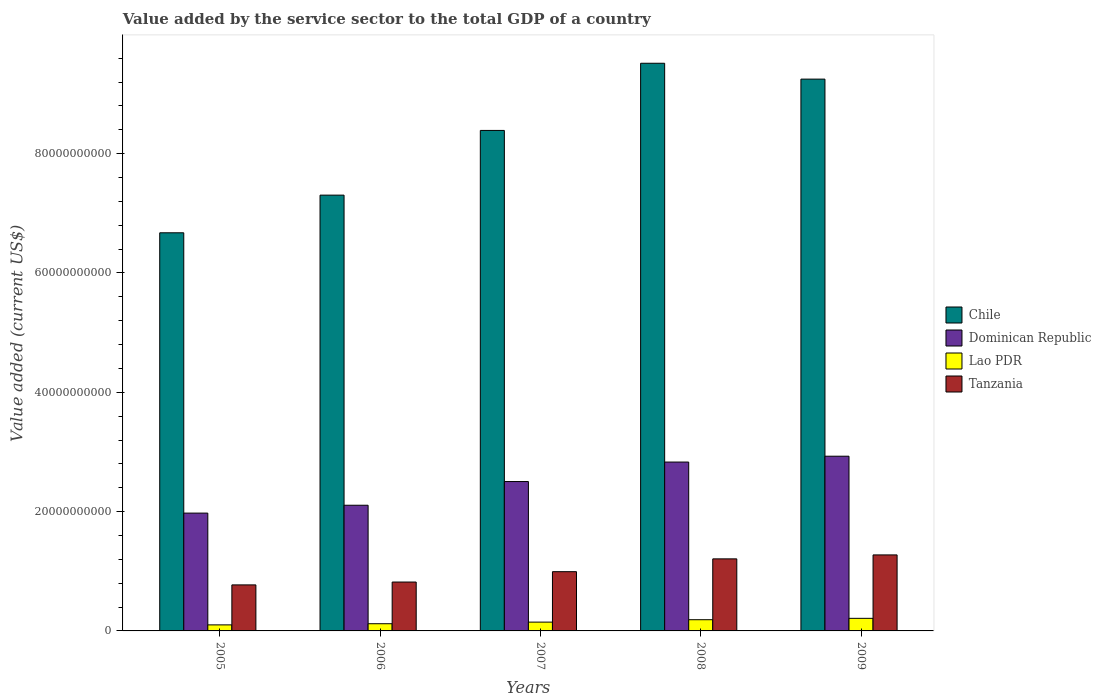How many groups of bars are there?
Provide a succinct answer. 5. Are the number of bars per tick equal to the number of legend labels?
Give a very brief answer. Yes. What is the label of the 5th group of bars from the left?
Your answer should be compact. 2009. What is the value added by the service sector to the total GDP in Lao PDR in 2006?
Provide a succinct answer. 1.21e+09. Across all years, what is the maximum value added by the service sector to the total GDP in Lao PDR?
Ensure brevity in your answer.  2.11e+09. Across all years, what is the minimum value added by the service sector to the total GDP in Chile?
Offer a terse response. 6.67e+1. In which year was the value added by the service sector to the total GDP in Dominican Republic maximum?
Make the answer very short. 2009. What is the total value added by the service sector to the total GDP in Tanzania in the graph?
Offer a terse response. 5.07e+1. What is the difference between the value added by the service sector to the total GDP in Tanzania in 2005 and that in 2008?
Make the answer very short. -4.36e+09. What is the difference between the value added by the service sector to the total GDP in Tanzania in 2007 and the value added by the service sector to the total GDP in Chile in 2009?
Provide a short and direct response. -8.26e+1. What is the average value added by the service sector to the total GDP in Chile per year?
Offer a terse response. 8.23e+1. In the year 2008, what is the difference between the value added by the service sector to the total GDP in Chile and value added by the service sector to the total GDP in Tanzania?
Ensure brevity in your answer.  8.31e+1. What is the ratio of the value added by the service sector to the total GDP in Tanzania in 2007 to that in 2009?
Provide a succinct answer. 0.78. Is the value added by the service sector to the total GDP in Dominican Republic in 2007 less than that in 2008?
Your response must be concise. Yes. What is the difference between the highest and the second highest value added by the service sector to the total GDP in Tanzania?
Your answer should be compact. 6.62e+08. What is the difference between the highest and the lowest value added by the service sector to the total GDP in Chile?
Give a very brief answer. 2.84e+1. In how many years, is the value added by the service sector to the total GDP in Tanzania greater than the average value added by the service sector to the total GDP in Tanzania taken over all years?
Provide a short and direct response. 2. Is the sum of the value added by the service sector to the total GDP in Tanzania in 2006 and 2008 greater than the maximum value added by the service sector to the total GDP in Lao PDR across all years?
Your answer should be compact. Yes. What does the 4th bar from the left in 2006 represents?
Offer a terse response. Tanzania. What does the 1st bar from the right in 2009 represents?
Keep it short and to the point. Tanzania. Is it the case that in every year, the sum of the value added by the service sector to the total GDP in Chile and value added by the service sector to the total GDP in Lao PDR is greater than the value added by the service sector to the total GDP in Dominican Republic?
Ensure brevity in your answer.  Yes. Are all the bars in the graph horizontal?
Offer a terse response. No. What is the difference between two consecutive major ticks on the Y-axis?
Keep it short and to the point. 2.00e+1. Are the values on the major ticks of Y-axis written in scientific E-notation?
Give a very brief answer. No. Does the graph contain any zero values?
Offer a very short reply. No. Where does the legend appear in the graph?
Offer a very short reply. Center right. How many legend labels are there?
Provide a succinct answer. 4. How are the legend labels stacked?
Your answer should be very brief. Vertical. What is the title of the graph?
Give a very brief answer. Value added by the service sector to the total GDP of a country. What is the label or title of the Y-axis?
Provide a short and direct response. Value added (current US$). What is the Value added (current US$) in Chile in 2005?
Provide a succinct answer. 6.67e+1. What is the Value added (current US$) of Dominican Republic in 2005?
Keep it short and to the point. 1.97e+1. What is the Value added (current US$) of Lao PDR in 2005?
Keep it short and to the point. 1.01e+09. What is the Value added (current US$) in Tanzania in 2005?
Keep it short and to the point. 7.71e+09. What is the Value added (current US$) in Chile in 2006?
Offer a very short reply. 7.30e+1. What is the Value added (current US$) in Dominican Republic in 2006?
Your response must be concise. 2.11e+1. What is the Value added (current US$) in Lao PDR in 2006?
Give a very brief answer. 1.21e+09. What is the Value added (current US$) of Tanzania in 2006?
Provide a short and direct response. 8.19e+09. What is the Value added (current US$) in Chile in 2007?
Give a very brief answer. 8.39e+1. What is the Value added (current US$) in Dominican Republic in 2007?
Provide a short and direct response. 2.50e+1. What is the Value added (current US$) of Lao PDR in 2007?
Your response must be concise. 1.48e+09. What is the Value added (current US$) in Tanzania in 2007?
Make the answer very short. 9.93e+09. What is the Value added (current US$) of Chile in 2008?
Your response must be concise. 9.51e+1. What is the Value added (current US$) of Dominican Republic in 2008?
Give a very brief answer. 2.83e+1. What is the Value added (current US$) of Lao PDR in 2008?
Give a very brief answer. 1.88e+09. What is the Value added (current US$) in Tanzania in 2008?
Make the answer very short. 1.21e+1. What is the Value added (current US$) in Chile in 2009?
Keep it short and to the point. 9.25e+1. What is the Value added (current US$) in Dominican Republic in 2009?
Ensure brevity in your answer.  2.93e+1. What is the Value added (current US$) of Lao PDR in 2009?
Provide a succinct answer. 2.11e+09. What is the Value added (current US$) of Tanzania in 2009?
Offer a very short reply. 1.27e+1. Across all years, what is the maximum Value added (current US$) in Chile?
Give a very brief answer. 9.51e+1. Across all years, what is the maximum Value added (current US$) of Dominican Republic?
Offer a very short reply. 2.93e+1. Across all years, what is the maximum Value added (current US$) in Lao PDR?
Your answer should be compact. 2.11e+09. Across all years, what is the maximum Value added (current US$) in Tanzania?
Make the answer very short. 1.27e+1. Across all years, what is the minimum Value added (current US$) in Chile?
Offer a very short reply. 6.67e+1. Across all years, what is the minimum Value added (current US$) in Dominican Republic?
Offer a very short reply. 1.97e+1. Across all years, what is the minimum Value added (current US$) in Lao PDR?
Give a very brief answer. 1.01e+09. Across all years, what is the minimum Value added (current US$) in Tanzania?
Keep it short and to the point. 7.71e+09. What is the total Value added (current US$) of Chile in the graph?
Offer a terse response. 4.11e+11. What is the total Value added (current US$) of Dominican Republic in the graph?
Keep it short and to the point. 1.23e+11. What is the total Value added (current US$) in Lao PDR in the graph?
Your answer should be compact. 7.68e+09. What is the total Value added (current US$) of Tanzania in the graph?
Keep it short and to the point. 5.07e+1. What is the difference between the Value added (current US$) in Chile in 2005 and that in 2006?
Provide a short and direct response. -6.31e+09. What is the difference between the Value added (current US$) of Dominican Republic in 2005 and that in 2006?
Offer a terse response. -1.32e+09. What is the difference between the Value added (current US$) of Lao PDR in 2005 and that in 2006?
Your response must be concise. -1.94e+08. What is the difference between the Value added (current US$) in Tanzania in 2005 and that in 2006?
Your answer should be compact. -4.79e+08. What is the difference between the Value added (current US$) in Chile in 2005 and that in 2007?
Your response must be concise. -1.72e+1. What is the difference between the Value added (current US$) in Dominican Republic in 2005 and that in 2007?
Your answer should be very brief. -5.29e+09. What is the difference between the Value added (current US$) in Lao PDR in 2005 and that in 2007?
Provide a succinct answer. -4.64e+08. What is the difference between the Value added (current US$) in Tanzania in 2005 and that in 2007?
Offer a very short reply. -2.21e+09. What is the difference between the Value added (current US$) of Chile in 2005 and that in 2008?
Keep it short and to the point. -2.84e+1. What is the difference between the Value added (current US$) of Dominican Republic in 2005 and that in 2008?
Your answer should be compact. -8.56e+09. What is the difference between the Value added (current US$) in Lao PDR in 2005 and that in 2008?
Your response must be concise. -8.67e+08. What is the difference between the Value added (current US$) in Tanzania in 2005 and that in 2008?
Your response must be concise. -4.36e+09. What is the difference between the Value added (current US$) of Chile in 2005 and that in 2009?
Make the answer very short. -2.58e+1. What is the difference between the Value added (current US$) of Dominican Republic in 2005 and that in 2009?
Offer a terse response. -9.54e+09. What is the difference between the Value added (current US$) in Lao PDR in 2005 and that in 2009?
Keep it short and to the point. -1.10e+09. What is the difference between the Value added (current US$) in Tanzania in 2005 and that in 2009?
Make the answer very short. -5.02e+09. What is the difference between the Value added (current US$) in Chile in 2006 and that in 2007?
Ensure brevity in your answer.  -1.08e+1. What is the difference between the Value added (current US$) in Dominican Republic in 2006 and that in 2007?
Your response must be concise. -3.97e+09. What is the difference between the Value added (current US$) in Lao PDR in 2006 and that in 2007?
Keep it short and to the point. -2.70e+08. What is the difference between the Value added (current US$) in Tanzania in 2006 and that in 2007?
Offer a terse response. -1.73e+09. What is the difference between the Value added (current US$) in Chile in 2006 and that in 2008?
Provide a succinct answer. -2.21e+1. What is the difference between the Value added (current US$) of Dominican Republic in 2006 and that in 2008?
Offer a terse response. -7.24e+09. What is the difference between the Value added (current US$) in Lao PDR in 2006 and that in 2008?
Ensure brevity in your answer.  -6.73e+08. What is the difference between the Value added (current US$) of Tanzania in 2006 and that in 2008?
Keep it short and to the point. -3.88e+09. What is the difference between the Value added (current US$) in Chile in 2006 and that in 2009?
Keep it short and to the point. -1.94e+1. What is the difference between the Value added (current US$) of Dominican Republic in 2006 and that in 2009?
Your response must be concise. -8.22e+09. What is the difference between the Value added (current US$) in Lao PDR in 2006 and that in 2009?
Keep it short and to the point. -9.02e+08. What is the difference between the Value added (current US$) of Tanzania in 2006 and that in 2009?
Give a very brief answer. -4.55e+09. What is the difference between the Value added (current US$) in Chile in 2007 and that in 2008?
Your answer should be compact. -1.13e+1. What is the difference between the Value added (current US$) in Dominican Republic in 2007 and that in 2008?
Give a very brief answer. -3.27e+09. What is the difference between the Value added (current US$) of Lao PDR in 2007 and that in 2008?
Your answer should be very brief. -4.03e+08. What is the difference between the Value added (current US$) in Tanzania in 2007 and that in 2008?
Offer a very short reply. -2.15e+09. What is the difference between the Value added (current US$) in Chile in 2007 and that in 2009?
Make the answer very short. -8.60e+09. What is the difference between the Value added (current US$) in Dominican Republic in 2007 and that in 2009?
Offer a very short reply. -4.25e+09. What is the difference between the Value added (current US$) of Lao PDR in 2007 and that in 2009?
Your answer should be very brief. -6.32e+08. What is the difference between the Value added (current US$) of Tanzania in 2007 and that in 2009?
Offer a terse response. -2.81e+09. What is the difference between the Value added (current US$) in Chile in 2008 and that in 2009?
Your answer should be compact. 2.66e+09. What is the difference between the Value added (current US$) in Dominican Republic in 2008 and that in 2009?
Your response must be concise. -9.80e+08. What is the difference between the Value added (current US$) in Lao PDR in 2008 and that in 2009?
Make the answer very short. -2.29e+08. What is the difference between the Value added (current US$) of Tanzania in 2008 and that in 2009?
Your answer should be very brief. -6.62e+08. What is the difference between the Value added (current US$) of Chile in 2005 and the Value added (current US$) of Dominican Republic in 2006?
Provide a short and direct response. 4.57e+1. What is the difference between the Value added (current US$) of Chile in 2005 and the Value added (current US$) of Lao PDR in 2006?
Offer a very short reply. 6.55e+1. What is the difference between the Value added (current US$) in Chile in 2005 and the Value added (current US$) in Tanzania in 2006?
Provide a short and direct response. 5.85e+1. What is the difference between the Value added (current US$) of Dominican Republic in 2005 and the Value added (current US$) of Lao PDR in 2006?
Provide a succinct answer. 1.85e+1. What is the difference between the Value added (current US$) in Dominican Republic in 2005 and the Value added (current US$) in Tanzania in 2006?
Offer a terse response. 1.16e+1. What is the difference between the Value added (current US$) in Lao PDR in 2005 and the Value added (current US$) in Tanzania in 2006?
Give a very brief answer. -7.18e+09. What is the difference between the Value added (current US$) of Chile in 2005 and the Value added (current US$) of Dominican Republic in 2007?
Your answer should be very brief. 4.17e+1. What is the difference between the Value added (current US$) in Chile in 2005 and the Value added (current US$) in Lao PDR in 2007?
Offer a very short reply. 6.53e+1. What is the difference between the Value added (current US$) in Chile in 2005 and the Value added (current US$) in Tanzania in 2007?
Provide a short and direct response. 5.68e+1. What is the difference between the Value added (current US$) of Dominican Republic in 2005 and the Value added (current US$) of Lao PDR in 2007?
Keep it short and to the point. 1.83e+1. What is the difference between the Value added (current US$) of Dominican Republic in 2005 and the Value added (current US$) of Tanzania in 2007?
Your answer should be compact. 9.82e+09. What is the difference between the Value added (current US$) in Lao PDR in 2005 and the Value added (current US$) in Tanzania in 2007?
Your answer should be very brief. -8.92e+09. What is the difference between the Value added (current US$) of Chile in 2005 and the Value added (current US$) of Dominican Republic in 2008?
Offer a terse response. 3.84e+1. What is the difference between the Value added (current US$) of Chile in 2005 and the Value added (current US$) of Lao PDR in 2008?
Provide a succinct answer. 6.49e+1. What is the difference between the Value added (current US$) of Chile in 2005 and the Value added (current US$) of Tanzania in 2008?
Ensure brevity in your answer.  5.47e+1. What is the difference between the Value added (current US$) in Dominican Republic in 2005 and the Value added (current US$) in Lao PDR in 2008?
Your response must be concise. 1.79e+1. What is the difference between the Value added (current US$) in Dominican Republic in 2005 and the Value added (current US$) in Tanzania in 2008?
Offer a very short reply. 7.67e+09. What is the difference between the Value added (current US$) in Lao PDR in 2005 and the Value added (current US$) in Tanzania in 2008?
Your response must be concise. -1.11e+1. What is the difference between the Value added (current US$) of Chile in 2005 and the Value added (current US$) of Dominican Republic in 2009?
Keep it short and to the point. 3.74e+1. What is the difference between the Value added (current US$) in Chile in 2005 and the Value added (current US$) in Lao PDR in 2009?
Make the answer very short. 6.46e+1. What is the difference between the Value added (current US$) in Chile in 2005 and the Value added (current US$) in Tanzania in 2009?
Offer a terse response. 5.40e+1. What is the difference between the Value added (current US$) in Dominican Republic in 2005 and the Value added (current US$) in Lao PDR in 2009?
Offer a terse response. 1.76e+1. What is the difference between the Value added (current US$) of Dominican Republic in 2005 and the Value added (current US$) of Tanzania in 2009?
Your answer should be compact. 7.01e+09. What is the difference between the Value added (current US$) in Lao PDR in 2005 and the Value added (current US$) in Tanzania in 2009?
Give a very brief answer. -1.17e+1. What is the difference between the Value added (current US$) of Chile in 2006 and the Value added (current US$) of Dominican Republic in 2007?
Ensure brevity in your answer.  4.80e+1. What is the difference between the Value added (current US$) in Chile in 2006 and the Value added (current US$) in Lao PDR in 2007?
Ensure brevity in your answer.  7.16e+1. What is the difference between the Value added (current US$) of Chile in 2006 and the Value added (current US$) of Tanzania in 2007?
Provide a succinct answer. 6.31e+1. What is the difference between the Value added (current US$) in Dominican Republic in 2006 and the Value added (current US$) in Lao PDR in 2007?
Provide a short and direct response. 1.96e+1. What is the difference between the Value added (current US$) of Dominican Republic in 2006 and the Value added (current US$) of Tanzania in 2007?
Provide a succinct answer. 1.11e+1. What is the difference between the Value added (current US$) in Lao PDR in 2006 and the Value added (current US$) in Tanzania in 2007?
Your answer should be compact. -8.72e+09. What is the difference between the Value added (current US$) in Chile in 2006 and the Value added (current US$) in Dominican Republic in 2008?
Your answer should be very brief. 4.47e+1. What is the difference between the Value added (current US$) in Chile in 2006 and the Value added (current US$) in Lao PDR in 2008?
Ensure brevity in your answer.  7.12e+1. What is the difference between the Value added (current US$) in Chile in 2006 and the Value added (current US$) in Tanzania in 2008?
Your response must be concise. 6.10e+1. What is the difference between the Value added (current US$) in Dominican Republic in 2006 and the Value added (current US$) in Lao PDR in 2008?
Your response must be concise. 1.92e+1. What is the difference between the Value added (current US$) in Dominican Republic in 2006 and the Value added (current US$) in Tanzania in 2008?
Offer a very short reply. 8.99e+09. What is the difference between the Value added (current US$) of Lao PDR in 2006 and the Value added (current US$) of Tanzania in 2008?
Offer a terse response. -1.09e+1. What is the difference between the Value added (current US$) in Chile in 2006 and the Value added (current US$) in Dominican Republic in 2009?
Make the answer very short. 4.38e+1. What is the difference between the Value added (current US$) in Chile in 2006 and the Value added (current US$) in Lao PDR in 2009?
Give a very brief answer. 7.09e+1. What is the difference between the Value added (current US$) of Chile in 2006 and the Value added (current US$) of Tanzania in 2009?
Your answer should be compact. 6.03e+1. What is the difference between the Value added (current US$) in Dominican Republic in 2006 and the Value added (current US$) in Lao PDR in 2009?
Make the answer very short. 1.90e+1. What is the difference between the Value added (current US$) in Dominican Republic in 2006 and the Value added (current US$) in Tanzania in 2009?
Provide a short and direct response. 8.33e+09. What is the difference between the Value added (current US$) in Lao PDR in 2006 and the Value added (current US$) in Tanzania in 2009?
Ensure brevity in your answer.  -1.15e+1. What is the difference between the Value added (current US$) in Chile in 2007 and the Value added (current US$) in Dominican Republic in 2008?
Provide a short and direct response. 5.56e+1. What is the difference between the Value added (current US$) in Chile in 2007 and the Value added (current US$) in Lao PDR in 2008?
Your response must be concise. 8.20e+1. What is the difference between the Value added (current US$) of Chile in 2007 and the Value added (current US$) of Tanzania in 2008?
Your answer should be very brief. 7.18e+1. What is the difference between the Value added (current US$) of Dominican Republic in 2007 and the Value added (current US$) of Lao PDR in 2008?
Provide a succinct answer. 2.32e+1. What is the difference between the Value added (current US$) in Dominican Republic in 2007 and the Value added (current US$) in Tanzania in 2008?
Your answer should be very brief. 1.30e+1. What is the difference between the Value added (current US$) in Lao PDR in 2007 and the Value added (current US$) in Tanzania in 2008?
Provide a succinct answer. -1.06e+1. What is the difference between the Value added (current US$) in Chile in 2007 and the Value added (current US$) in Dominican Republic in 2009?
Your answer should be compact. 5.46e+1. What is the difference between the Value added (current US$) in Chile in 2007 and the Value added (current US$) in Lao PDR in 2009?
Your response must be concise. 8.18e+1. What is the difference between the Value added (current US$) in Chile in 2007 and the Value added (current US$) in Tanzania in 2009?
Your answer should be very brief. 7.11e+1. What is the difference between the Value added (current US$) in Dominican Republic in 2007 and the Value added (current US$) in Lao PDR in 2009?
Your answer should be compact. 2.29e+1. What is the difference between the Value added (current US$) of Dominican Republic in 2007 and the Value added (current US$) of Tanzania in 2009?
Ensure brevity in your answer.  1.23e+1. What is the difference between the Value added (current US$) in Lao PDR in 2007 and the Value added (current US$) in Tanzania in 2009?
Ensure brevity in your answer.  -1.13e+1. What is the difference between the Value added (current US$) of Chile in 2008 and the Value added (current US$) of Dominican Republic in 2009?
Offer a very short reply. 6.59e+1. What is the difference between the Value added (current US$) in Chile in 2008 and the Value added (current US$) in Lao PDR in 2009?
Provide a short and direct response. 9.30e+1. What is the difference between the Value added (current US$) of Chile in 2008 and the Value added (current US$) of Tanzania in 2009?
Keep it short and to the point. 8.24e+1. What is the difference between the Value added (current US$) of Dominican Republic in 2008 and the Value added (current US$) of Lao PDR in 2009?
Offer a very short reply. 2.62e+1. What is the difference between the Value added (current US$) of Dominican Republic in 2008 and the Value added (current US$) of Tanzania in 2009?
Your answer should be very brief. 1.56e+1. What is the difference between the Value added (current US$) in Lao PDR in 2008 and the Value added (current US$) in Tanzania in 2009?
Your answer should be very brief. -1.09e+1. What is the average Value added (current US$) of Chile per year?
Provide a succinct answer. 8.23e+1. What is the average Value added (current US$) of Dominican Republic per year?
Your answer should be very brief. 2.47e+1. What is the average Value added (current US$) in Lao PDR per year?
Offer a very short reply. 1.54e+09. What is the average Value added (current US$) of Tanzania per year?
Make the answer very short. 1.01e+1. In the year 2005, what is the difference between the Value added (current US$) of Chile and Value added (current US$) of Dominican Republic?
Make the answer very short. 4.70e+1. In the year 2005, what is the difference between the Value added (current US$) of Chile and Value added (current US$) of Lao PDR?
Ensure brevity in your answer.  6.57e+1. In the year 2005, what is the difference between the Value added (current US$) in Chile and Value added (current US$) in Tanzania?
Offer a very short reply. 5.90e+1. In the year 2005, what is the difference between the Value added (current US$) in Dominican Republic and Value added (current US$) in Lao PDR?
Offer a very short reply. 1.87e+1. In the year 2005, what is the difference between the Value added (current US$) of Dominican Republic and Value added (current US$) of Tanzania?
Your response must be concise. 1.20e+1. In the year 2005, what is the difference between the Value added (current US$) in Lao PDR and Value added (current US$) in Tanzania?
Ensure brevity in your answer.  -6.70e+09. In the year 2006, what is the difference between the Value added (current US$) in Chile and Value added (current US$) in Dominican Republic?
Your answer should be very brief. 5.20e+1. In the year 2006, what is the difference between the Value added (current US$) of Chile and Value added (current US$) of Lao PDR?
Your answer should be very brief. 7.18e+1. In the year 2006, what is the difference between the Value added (current US$) in Chile and Value added (current US$) in Tanzania?
Ensure brevity in your answer.  6.48e+1. In the year 2006, what is the difference between the Value added (current US$) in Dominican Republic and Value added (current US$) in Lao PDR?
Give a very brief answer. 1.99e+1. In the year 2006, what is the difference between the Value added (current US$) of Dominican Republic and Value added (current US$) of Tanzania?
Your answer should be very brief. 1.29e+1. In the year 2006, what is the difference between the Value added (current US$) of Lao PDR and Value added (current US$) of Tanzania?
Provide a short and direct response. -6.99e+09. In the year 2007, what is the difference between the Value added (current US$) of Chile and Value added (current US$) of Dominican Republic?
Make the answer very short. 5.88e+1. In the year 2007, what is the difference between the Value added (current US$) of Chile and Value added (current US$) of Lao PDR?
Offer a terse response. 8.24e+1. In the year 2007, what is the difference between the Value added (current US$) of Chile and Value added (current US$) of Tanzania?
Your answer should be very brief. 7.40e+1. In the year 2007, what is the difference between the Value added (current US$) in Dominican Republic and Value added (current US$) in Lao PDR?
Offer a terse response. 2.36e+1. In the year 2007, what is the difference between the Value added (current US$) in Dominican Republic and Value added (current US$) in Tanzania?
Your answer should be very brief. 1.51e+1. In the year 2007, what is the difference between the Value added (current US$) in Lao PDR and Value added (current US$) in Tanzania?
Make the answer very short. -8.45e+09. In the year 2008, what is the difference between the Value added (current US$) of Chile and Value added (current US$) of Dominican Republic?
Ensure brevity in your answer.  6.68e+1. In the year 2008, what is the difference between the Value added (current US$) of Chile and Value added (current US$) of Lao PDR?
Keep it short and to the point. 9.33e+1. In the year 2008, what is the difference between the Value added (current US$) of Chile and Value added (current US$) of Tanzania?
Your response must be concise. 8.31e+1. In the year 2008, what is the difference between the Value added (current US$) in Dominican Republic and Value added (current US$) in Lao PDR?
Ensure brevity in your answer.  2.64e+1. In the year 2008, what is the difference between the Value added (current US$) of Dominican Republic and Value added (current US$) of Tanzania?
Make the answer very short. 1.62e+1. In the year 2008, what is the difference between the Value added (current US$) in Lao PDR and Value added (current US$) in Tanzania?
Your response must be concise. -1.02e+1. In the year 2009, what is the difference between the Value added (current US$) in Chile and Value added (current US$) in Dominican Republic?
Offer a very short reply. 6.32e+1. In the year 2009, what is the difference between the Value added (current US$) in Chile and Value added (current US$) in Lao PDR?
Your response must be concise. 9.04e+1. In the year 2009, what is the difference between the Value added (current US$) of Chile and Value added (current US$) of Tanzania?
Your answer should be compact. 7.97e+1. In the year 2009, what is the difference between the Value added (current US$) in Dominican Republic and Value added (current US$) in Lao PDR?
Your response must be concise. 2.72e+1. In the year 2009, what is the difference between the Value added (current US$) in Dominican Republic and Value added (current US$) in Tanzania?
Keep it short and to the point. 1.65e+1. In the year 2009, what is the difference between the Value added (current US$) of Lao PDR and Value added (current US$) of Tanzania?
Give a very brief answer. -1.06e+1. What is the ratio of the Value added (current US$) of Chile in 2005 to that in 2006?
Ensure brevity in your answer.  0.91. What is the ratio of the Value added (current US$) in Dominican Republic in 2005 to that in 2006?
Make the answer very short. 0.94. What is the ratio of the Value added (current US$) in Lao PDR in 2005 to that in 2006?
Your response must be concise. 0.84. What is the ratio of the Value added (current US$) of Tanzania in 2005 to that in 2006?
Provide a succinct answer. 0.94. What is the ratio of the Value added (current US$) of Chile in 2005 to that in 2007?
Your response must be concise. 0.8. What is the ratio of the Value added (current US$) of Dominican Republic in 2005 to that in 2007?
Ensure brevity in your answer.  0.79. What is the ratio of the Value added (current US$) in Lao PDR in 2005 to that in 2007?
Give a very brief answer. 0.69. What is the ratio of the Value added (current US$) of Tanzania in 2005 to that in 2007?
Your response must be concise. 0.78. What is the ratio of the Value added (current US$) of Chile in 2005 to that in 2008?
Your answer should be very brief. 0.7. What is the ratio of the Value added (current US$) in Dominican Republic in 2005 to that in 2008?
Ensure brevity in your answer.  0.7. What is the ratio of the Value added (current US$) in Lao PDR in 2005 to that in 2008?
Offer a terse response. 0.54. What is the ratio of the Value added (current US$) in Tanzania in 2005 to that in 2008?
Offer a very short reply. 0.64. What is the ratio of the Value added (current US$) of Chile in 2005 to that in 2009?
Give a very brief answer. 0.72. What is the ratio of the Value added (current US$) in Dominican Republic in 2005 to that in 2009?
Offer a very short reply. 0.67. What is the ratio of the Value added (current US$) of Lao PDR in 2005 to that in 2009?
Provide a short and direct response. 0.48. What is the ratio of the Value added (current US$) in Tanzania in 2005 to that in 2009?
Your answer should be compact. 0.61. What is the ratio of the Value added (current US$) in Chile in 2006 to that in 2007?
Your response must be concise. 0.87. What is the ratio of the Value added (current US$) in Dominican Republic in 2006 to that in 2007?
Keep it short and to the point. 0.84. What is the ratio of the Value added (current US$) of Lao PDR in 2006 to that in 2007?
Your response must be concise. 0.82. What is the ratio of the Value added (current US$) of Tanzania in 2006 to that in 2007?
Provide a succinct answer. 0.83. What is the ratio of the Value added (current US$) in Chile in 2006 to that in 2008?
Your answer should be compact. 0.77. What is the ratio of the Value added (current US$) in Dominican Republic in 2006 to that in 2008?
Ensure brevity in your answer.  0.74. What is the ratio of the Value added (current US$) in Lao PDR in 2006 to that in 2008?
Make the answer very short. 0.64. What is the ratio of the Value added (current US$) in Tanzania in 2006 to that in 2008?
Provide a succinct answer. 0.68. What is the ratio of the Value added (current US$) of Chile in 2006 to that in 2009?
Provide a succinct answer. 0.79. What is the ratio of the Value added (current US$) of Dominican Republic in 2006 to that in 2009?
Provide a short and direct response. 0.72. What is the ratio of the Value added (current US$) of Lao PDR in 2006 to that in 2009?
Your answer should be compact. 0.57. What is the ratio of the Value added (current US$) in Tanzania in 2006 to that in 2009?
Offer a terse response. 0.64. What is the ratio of the Value added (current US$) in Chile in 2007 to that in 2008?
Keep it short and to the point. 0.88. What is the ratio of the Value added (current US$) of Dominican Republic in 2007 to that in 2008?
Keep it short and to the point. 0.88. What is the ratio of the Value added (current US$) of Lao PDR in 2007 to that in 2008?
Give a very brief answer. 0.79. What is the ratio of the Value added (current US$) in Tanzania in 2007 to that in 2008?
Give a very brief answer. 0.82. What is the ratio of the Value added (current US$) in Chile in 2007 to that in 2009?
Provide a succinct answer. 0.91. What is the ratio of the Value added (current US$) of Dominican Republic in 2007 to that in 2009?
Offer a very short reply. 0.85. What is the ratio of the Value added (current US$) in Lao PDR in 2007 to that in 2009?
Make the answer very short. 0.7. What is the ratio of the Value added (current US$) of Tanzania in 2007 to that in 2009?
Your response must be concise. 0.78. What is the ratio of the Value added (current US$) in Chile in 2008 to that in 2009?
Provide a short and direct response. 1.03. What is the ratio of the Value added (current US$) in Dominican Republic in 2008 to that in 2009?
Provide a succinct answer. 0.97. What is the ratio of the Value added (current US$) in Lao PDR in 2008 to that in 2009?
Provide a short and direct response. 0.89. What is the ratio of the Value added (current US$) in Tanzania in 2008 to that in 2009?
Provide a succinct answer. 0.95. What is the difference between the highest and the second highest Value added (current US$) in Chile?
Provide a succinct answer. 2.66e+09. What is the difference between the highest and the second highest Value added (current US$) of Dominican Republic?
Provide a short and direct response. 9.80e+08. What is the difference between the highest and the second highest Value added (current US$) of Lao PDR?
Give a very brief answer. 2.29e+08. What is the difference between the highest and the second highest Value added (current US$) in Tanzania?
Make the answer very short. 6.62e+08. What is the difference between the highest and the lowest Value added (current US$) of Chile?
Ensure brevity in your answer.  2.84e+1. What is the difference between the highest and the lowest Value added (current US$) in Dominican Republic?
Provide a succinct answer. 9.54e+09. What is the difference between the highest and the lowest Value added (current US$) of Lao PDR?
Give a very brief answer. 1.10e+09. What is the difference between the highest and the lowest Value added (current US$) of Tanzania?
Offer a very short reply. 5.02e+09. 